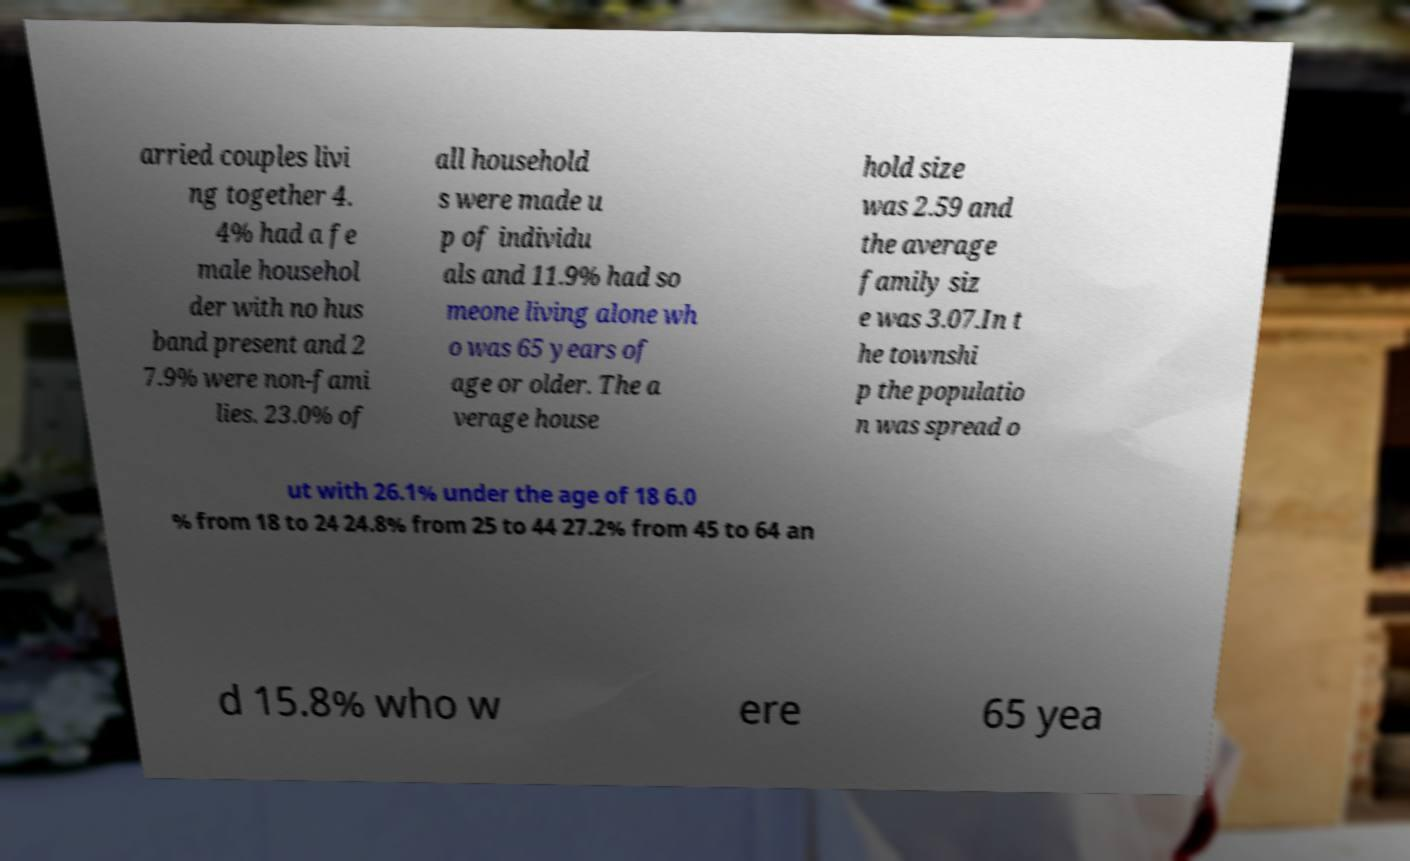Could you extract and type out the text from this image? arried couples livi ng together 4. 4% had a fe male househol der with no hus band present and 2 7.9% were non-fami lies. 23.0% of all household s were made u p of individu als and 11.9% had so meone living alone wh o was 65 years of age or older. The a verage house hold size was 2.59 and the average family siz e was 3.07.In t he townshi p the populatio n was spread o ut with 26.1% under the age of 18 6.0 % from 18 to 24 24.8% from 25 to 44 27.2% from 45 to 64 an d 15.8% who w ere 65 yea 